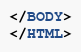Convert code to text. <code><loc_0><loc_0><loc_500><loc_500><_HTML_></BODY>
</HTML>
</code> 